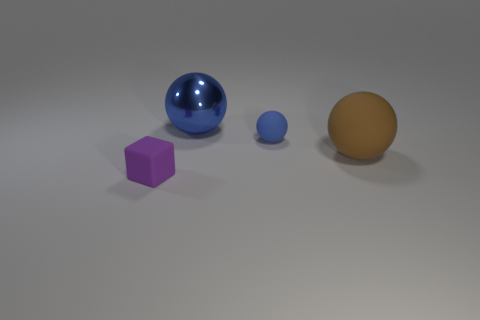Can you describe the objects and their arrangement in the image? Certainly! The image displays a collection of four objects resting on a flat surface against a neutral background. From left to right, there is a purple cube, a large blue sphere with a reflective surface, a smaller blue sphere, and a large opaque brown sphere. The objects are spaced apart and appear to be isolated with no overlap from this perspective. 